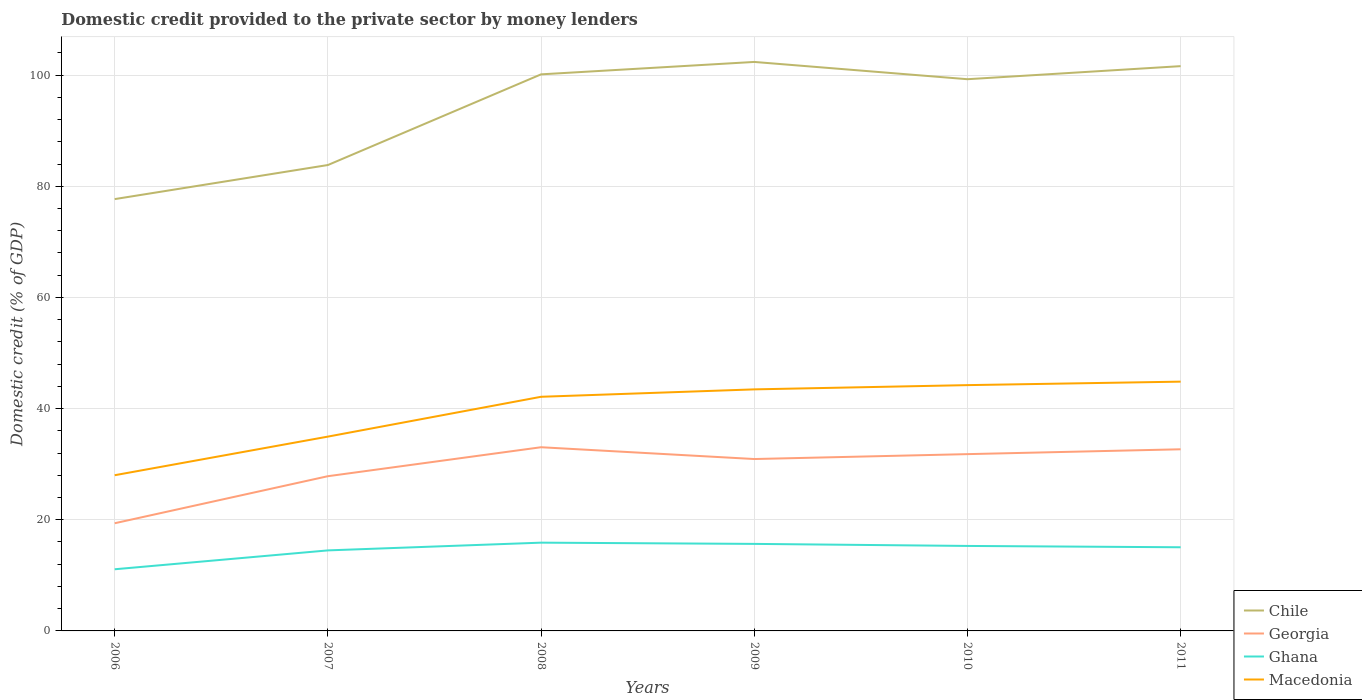How many different coloured lines are there?
Your answer should be compact. 4. Does the line corresponding to Georgia intersect with the line corresponding to Macedonia?
Keep it short and to the point. No. Across all years, what is the maximum domestic credit provided to the private sector by money lenders in Ghana?
Give a very brief answer. 11.09. What is the total domestic credit provided to the private sector by money lenders in Georgia in the graph?
Ensure brevity in your answer.  -0.87. What is the difference between the highest and the second highest domestic credit provided to the private sector by money lenders in Chile?
Your response must be concise. 24.68. What is the difference between two consecutive major ticks on the Y-axis?
Your answer should be compact. 20. Are the values on the major ticks of Y-axis written in scientific E-notation?
Make the answer very short. No. Where does the legend appear in the graph?
Your answer should be compact. Bottom right. How many legend labels are there?
Keep it short and to the point. 4. How are the legend labels stacked?
Give a very brief answer. Vertical. What is the title of the graph?
Your answer should be very brief. Domestic credit provided to the private sector by money lenders. What is the label or title of the X-axis?
Give a very brief answer. Years. What is the label or title of the Y-axis?
Your answer should be compact. Domestic credit (% of GDP). What is the Domestic credit (% of GDP) in Chile in 2006?
Provide a succinct answer. 77.69. What is the Domestic credit (% of GDP) in Georgia in 2006?
Offer a very short reply. 19.37. What is the Domestic credit (% of GDP) in Ghana in 2006?
Offer a terse response. 11.09. What is the Domestic credit (% of GDP) of Macedonia in 2006?
Keep it short and to the point. 28.01. What is the Domestic credit (% of GDP) in Chile in 2007?
Your response must be concise. 83.82. What is the Domestic credit (% of GDP) of Georgia in 2007?
Your answer should be compact. 27.84. What is the Domestic credit (% of GDP) in Ghana in 2007?
Provide a short and direct response. 14.49. What is the Domestic credit (% of GDP) in Macedonia in 2007?
Your answer should be compact. 34.96. What is the Domestic credit (% of GDP) of Chile in 2008?
Provide a short and direct response. 100.14. What is the Domestic credit (% of GDP) in Georgia in 2008?
Provide a succinct answer. 33.05. What is the Domestic credit (% of GDP) of Ghana in 2008?
Give a very brief answer. 15.88. What is the Domestic credit (% of GDP) in Macedonia in 2008?
Provide a succinct answer. 42.13. What is the Domestic credit (% of GDP) in Chile in 2009?
Offer a terse response. 102.37. What is the Domestic credit (% of GDP) in Georgia in 2009?
Offer a very short reply. 30.93. What is the Domestic credit (% of GDP) of Ghana in 2009?
Make the answer very short. 15.66. What is the Domestic credit (% of GDP) of Macedonia in 2009?
Provide a short and direct response. 43.46. What is the Domestic credit (% of GDP) in Chile in 2010?
Offer a terse response. 99.27. What is the Domestic credit (% of GDP) in Georgia in 2010?
Provide a short and direct response. 31.81. What is the Domestic credit (% of GDP) in Ghana in 2010?
Make the answer very short. 15.29. What is the Domestic credit (% of GDP) in Macedonia in 2010?
Provide a short and direct response. 44.22. What is the Domestic credit (% of GDP) of Chile in 2011?
Offer a terse response. 101.62. What is the Domestic credit (% of GDP) of Georgia in 2011?
Give a very brief answer. 32.68. What is the Domestic credit (% of GDP) of Ghana in 2011?
Keep it short and to the point. 15.05. What is the Domestic credit (% of GDP) of Macedonia in 2011?
Ensure brevity in your answer.  44.85. Across all years, what is the maximum Domestic credit (% of GDP) of Chile?
Your answer should be very brief. 102.37. Across all years, what is the maximum Domestic credit (% of GDP) in Georgia?
Offer a very short reply. 33.05. Across all years, what is the maximum Domestic credit (% of GDP) in Ghana?
Your response must be concise. 15.88. Across all years, what is the maximum Domestic credit (% of GDP) in Macedonia?
Ensure brevity in your answer.  44.85. Across all years, what is the minimum Domestic credit (% of GDP) of Chile?
Make the answer very short. 77.69. Across all years, what is the minimum Domestic credit (% of GDP) of Georgia?
Provide a succinct answer. 19.37. Across all years, what is the minimum Domestic credit (% of GDP) of Ghana?
Keep it short and to the point. 11.09. Across all years, what is the minimum Domestic credit (% of GDP) of Macedonia?
Ensure brevity in your answer.  28.01. What is the total Domestic credit (% of GDP) of Chile in the graph?
Keep it short and to the point. 564.91. What is the total Domestic credit (% of GDP) of Georgia in the graph?
Offer a very short reply. 175.68. What is the total Domestic credit (% of GDP) of Ghana in the graph?
Your response must be concise. 87.46. What is the total Domestic credit (% of GDP) in Macedonia in the graph?
Give a very brief answer. 237.64. What is the difference between the Domestic credit (% of GDP) of Chile in 2006 and that in 2007?
Ensure brevity in your answer.  -6.13. What is the difference between the Domestic credit (% of GDP) of Georgia in 2006 and that in 2007?
Offer a terse response. -8.46. What is the difference between the Domestic credit (% of GDP) in Ghana in 2006 and that in 2007?
Offer a terse response. -3.39. What is the difference between the Domestic credit (% of GDP) of Macedonia in 2006 and that in 2007?
Your response must be concise. -6.95. What is the difference between the Domestic credit (% of GDP) in Chile in 2006 and that in 2008?
Provide a succinct answer. -22.45. What is the difference between the Domestic credit (% of GDP) of Georgia in 2006 and that in 2008?
Ensure brevity in your answer.  -13.68. What is the difference between the Domestic credit (% of GDP) in Ghana in 2006 and that in 2008?
Your answer should be compact. -4.79. What is the difference between the Domestic credit (% of GDP) of Macedonia in 2006 and that in 2008?
Give a very brief answer. -14.11. What is the difference between the Domestic credit (% of GDP) of Chile in 2006 and that in 2009?
Ensure brevity in your answer.  -24.68. What is the difference between the Domestic credit (% of GDP) in Georgia in 2006 and that in 2009?
Offer a very short reply. -11.55. What is the difference between the Domestic credit (% of GDP) of Ghana in 2006 and that in 2009?
Provide a short and direct response. -4.56. What is the difference between the Domestic credit (% of GDP) in Macedonia in 2006 and that in 2009?
Make the answer very short. -15.45. What is the difference between the Domestic credit (% of GDP) of Chile in 2006 and that in 2010?
Keep it short and to the point. -21.57. What is the difference between the Domestic credit (% of GDP) in Georgia in 2006 and that in 2010?
Give a very brief answer. -12.43. What is the difference between the Domestic credit (% of GDP) in Ghana in 2006 and that in 2010?
Provide a succinct answer. -4.2. What is the difference between the Domestic credit (% of GDP) of Macedonia in 2006 and that in 2010?
Provide a succinct answer. -16.21. What is the difference between the Domestic credit (% of GDP) of Chile in 2006 and that in 2011?
Give a very brief answer. -23.92. What is the difference between the Domestic credit (% of GDP) in Georgia in 2006 and that in 2011?
Provide a succinct answer. -13.31. What is the difference between the Domestic credit (% of GDP) in Ghana in 2006 and that in 2011?
Make the answer very short. -3.96. What is the difference between the Domestic credit (% of GDP) in Macedonia in 2006 and that in 2011?
Offer a terse response. -16.84. What is the difference between the Domestic credit (% of GDP) of Chile in 2007 and that in 2008?
Your response must be concise. -16.32. What is the difference between the Domestic credit (% of GDP) of Georgia in 2007 and that in 2008?
Ensure brevity in your answer.  -5.21. What is the difference between the Domestic credit (% of GDP) in Ghana in 2007 and that in 2008?
Offer a terse response. -1.39. What is the difference between the Domestic credit (% of GDP) in Macedonia in 2007 and that in 2008?
Your answer should be very brief. -7.17. What is the difference between the Domestic credit (% of GDP) of Chile in 2007 and that in 2009?
Give a very brief answer. -18.55. What is the difference between the Domestic credit (% of GDP) of Georgia in 2007 and that in 2009?
Provide a short and direct response. -3.09. What is the difference between the Domestic credit (% of GDP) in Ghana in 2007 and that in 2009?
Your answer should be very brief. -1.17. What is the difference between the Domestic credit (% of GDP) in Macedonia in 2007 and that in 2009?
Give a very brief answer. -8.5. What is the difference between the Domestic credit (% of GDP) in Chile in 2007 and that in 2010?
Offer a terse response. -15.44. What is the difference between the Domestic credit (% of GDP) in Georgia in 2007 and that in 2010?
Make the answer very short. -3.97. What is the difference between the Domestic credit (% of GDP) in Ghana in 2007 and that in 2010?
Your answer should be very brief. -0.8. What is the difference between the Domestic credit (% of GDP) of Macedonia in 2007 and that in 2010?
Your answer should be very brief. -9.26. What is the difference between the Domestic credit (% of GDP) of Chile in 2007 and that in 2011?
Provide a short and direct response. -17.79. What is the difference between the Domestic credit (% of GDP) in Georgia in 2007 and that in 2011?
Your response must be concise. -4.84. What is the difference between the Domestic credit (% of GDP) of Ghana in 2007 and that in 2011?
Offer a terse response. -0.56. What is the difference between the Domestic credit (% of GDP) of Macedonia in 2007 and that in 2011?
Your response must be concise. -9.89. What is the difference between the Domestic credit (% of GDP) of Chile in 2008 and that in 2009?
Make the answer very short. -2.23. What is the difference between the Domestic credit (% of GDP) in Georgia in 2008 and that in 2009?
Provide a succinct answer. 2.12. What is the difference between the Domestic credit (% of GDP) in Ghana in 2008 and that in 2009?
Your answer should be compact. 0.22. What is the difference between the Domestic credit (% of GDP) in Macedonia in 2008 and that in 2009?
Your response must be concise. -1.33. What is the difference between the Domestic credit (% of GDP) in Chile in 2008 and that in 2010?
Offer a very short reply. 0.87. What is the difference between the Domestic credit (% of GDP) of Georgia in 2008 and that in 2010?
Keep it short and to the point. 1.24. What is the difference between the Domestic credit (% of GDP) in Ghana in 2008 and that in 2010?
Give a very brief answer. 0.59. What is the difference between the Domestic credit (% of GDP) of Macedonia in 2008 and that in 2010?
Offer a terse response. -2.1. What is the difference between the Domestic credit (% of GDP) of Chile in 2008 and that in 2011?
Your answer should be very brief. -1.48. What is the difference between the Domestic credit (% of GDP) in Georgia in 2008 and that in 2011?
Your response must be concise. 0.37. What is the difference between the Domestic credit (% of GDP) of Ghana in 2008 and that in 2011?
Offer a terse response. 0.83. What is the difference between the Domestic credit (% of GDP) of Macedonia in 2008 and that in 2011?
Give a very brief answer. -2.73. What is the difference between the Domestic credit (% of GDP) in Chile in 2009 and that in 2010?
Your answer should be compact. 3.11. What is the difference between the Domestic credit (% of GDP) of Georgia in 2009 and that in 2010?
Give a very brief answer. -0.88. What is the difference between the Domestic credit (% of GDP) in Ghana in 2009 and that in 2010?
Your answer should be compact. 0.37. What is the difference between the Domestic credit (% of GDP) of Macedonia in 2009 and that in 2010?
Offer a terse response. -0.76. What is the difference between the Domestic credit (% of GDP) in Chile in 2009 and that in 2011?
Offer a very short reply. 0.76. What is the difference between the Domestic credit (% of GDP) in Georgia in 2009 and that in 2011?
Ensure brevity in your answer.  -1.75. What is the difference between the Domestic credit (% of GDP) in Ghana in 2009 and that in 2011?
Keep it short and to the point. 0.61. What is the difference between the Domestic credit (% of GDP) of Macedonia in 2009 and that in 2011?
Keep it short and to the point. -1.39. What is the difference between the Domestic credit (% of GDP) in Chile in 2010 and that in 2011?
Make the answer very short. -2.35. What is the difference between the Domestic credit (% of GDP) of Georgia in 2010 and that in 2011?
Ensure brevity in your answer.  -0.87. What is the difference between the Domestic credit (% of GDP) of Ghana in 2010 and that in 2011?
Ensure brevity in your answer.  0.24. What is the difference between the Domestic credit (% of GDP) of Macedonia in 2010 and that in 2011?
Give a very brief answer. -0.63. What is the difference between the Domestic credit (% of GDP) in Chile in 2006 and the Domestic credit (% of GDP) in Georgia in 2007?
Make the answer very short. 49.86. What is the difference between the Domestic credit (% of GDP) in Chile in 2006 and the Domestic credit (% of GDP) in Ghana in 2007?
Make the answer very short. 63.21. What is the difference between the Domestic credit (% of GDP) of Chile in 2006 and the Domestic credit (% of GDP) of Macedonia in 2007?
Your response must be concise. 42.73. What is the difference between the Domestic credit (% of GDP) in Georgia in 2006 and the Domestic credit (% of GDP) in Ghana in 2007?
Make the answer very short. 4.89. What is the difference between the Domestic credit (% of GDP) in Georgia in 2006 and the Domestic credit (% of GDP) in Macedonia in 2007?
Make the answer very short. -15.59. What is the difference between the Domestic credit (% of GDP) in Ghana in 2006 and the Domestic credit (% of GDP) in Macedonia in 2007?
Provide a succinct answer. -23.87. What is the difference between the Domestic credit (% of GDP) of Chile in 2006 and the Domestic credit (% of GDP) of Georgia in 2008?
Your answer should be compact. 44.64. What is the difference between the Domestic credit (% of GDP) of Chile in 2006 and the Domestic credit (% of GDP) of Ghana in 2008?
Keep it short and to the point. 61.81. What is the difference between the Domestic credit (% of GDP) of Chile in 2006 and the Domestic credit (% of GDP) of Macedonia in 2008?
Your response must be concise. 35.57. What is the difference between the Domestic credit (% of GDP) of Georgia in 2006 and the Domestic credit (% of GDP) of Ghana in 2008?
Offer a terse response. 3.49. What is the difference between the Domestic credit (% of GDP) of Georgia in 2006 and the Domestic credit (% of GDP) of Macedonia in 2008?
Give a very brief answer. -22.75. What is the difference between the Domestic credit (% of GDP) of Ghana in 2006 and the Domestic credit (% of GDP) of Macedonia in 2008?
Your answer should be compact. -31.03. What is the difference between the Domestic credit (% of GDP) of Chile in 2006 and the Domestic credit (% of GDP) of Georgia in 2009?
Offer a terse response. 46.77. What is the difference between the Domestic credit (% of GDP) of Chile in 2006 and the Domestic credit (% of GDP) of Ghana in 2009?
Your answer should be compact. 62.04. What is the difference between the Domestic credit (% of GDP) of Chile in 2006 and the Domestic credit (% of GDP) of Macedonia in 2009?
Your response must be concise. 34.23. What is the difference between the Domestic credit (% of GDP) of Georgia in 2006 and the Domestic credit (% of GDP) of Ghana in 2009?
Ensure brevity in your answer.  3.72. What is the difference between the Domestic credit (% of GDP) in Georgia in 2006 and the Domestic credit (% of GDP) in Macedonia in 2009?
Offer a very short reply. -24.09. What is the difference between the Domestic credit (% of GDP) in Ghana in 2006 and the Domestic credit (% of GDP) in Macedonia in 2009?
Ensure brevity in your answer.  -32.37. What is the difference between the Domestic credit (% of GDP) of Chile in 2006 and the Domestic credit (% of GDP) of Georgia in 2010?
Your answer should be very brief. 45.89. What is the difference between the Domestic credit (% of GDP) in Chile in 2006 and the Domestic credit (% of GDP) in Ghana in 2010?
Your answer should be compact. 62.4. What is the difference between the Domestic credit (% of GDP) in Chile in 2006 and the Domestic credit (% of GDP) in Macedonia in 2010?
Your answer should be compact. 33.47. What is the difference between the Domestic credit (% of GDP) in Georgia in 2006 and the Domestic credit (% of GDP) in Ghana in 2010?
Your answer should be compact. 4.08. What is the difference between the Domestic credit (% of GDP) in Georgia in 2006 and the Domestic credit (% of GDP) in Macedonia in 2010?
Offer a very short reply. -24.85. What is the difference between the Domestic credit (% of GDP) of Ghana in 2006 and the Domestic credit (% of GDP) of Macedonia in 2010?
Your answer should be very brief. -33.13. What is the difference between the Domestic credit (% of GDP) in Chile in 2006 and the Domestic credit (% of GDP) in Georgia in 2011?
Offer a terse response. 45.01. What is the difference between the Domestic credit (% of GDP) in Chile in 2006 and the Domestic credit (% of GDP) in Ghana in 2011?
Give a very brief answer. 62.64. What is the difference between the Domestic credit (% of GDP) in Chile in 2006 and the Domestic credit (% of GDP) in Macedonia in 2011?
Provide a short and direct response. 32.84. What is the difference between the Domestic credit (% of GDP) of Georgia in 2006 and the Domestic credit (% of GDP) of Ghana in 2011?
Make the answer very short. 4.32. What is the difference between the Domestic credit (% of GDP) in Georgia in 2006 and the Domestic credit (% of GDP) in Macedonia in 2011?
Your answer should be compact. -25.48. What is the difference between the Domestic credit (% of GDP) in Ghana in 2006 and the Domestic credit (% of GDP) in Macedonia in 2011?
Your response must be concise. -33.76. What is the difference between the Domestic credit (% of GDP) in Chile in 2007 and the Domestic credit (% of GDP) in Georgia in 2008?
Your response must be concise. 50.77. What is the difference between the Domestic credit (% of GDP) in Chile in 2007 and the Domestic credit (% of GDP) in Ghana in 2008?
Make the answer very short. 67.94. What is the difference between the Domestic credit (% of GDP) of Chile in 2007 and the Domestic credit (% of GDP) of Macedonia in 2008?
Your response must be concise. 41.7. What is the difference between the Domestic credit (% of GDP) of Georgia in 2007 and the Domestic credit (% of GDP) of Ghana in 2008?
Ensure brevity in your answer.  11.96. What is the difference between the Domestic credit (% of GDP) in Georgia in 2007 and the Domestic credit (% of GDP) in Macedonia in 2008?
Your answer should be compact. -14.29. What is the difference between the Domestic credit (% of GDP) in Ghana in 2007 and the Domestic credit (% of GDP) in Macedonia in 2008?
Your response must be concise. -27.64. What is the difference between the Domestic credit (% of GDP) in Chile in 2007 and the Domestic credit (% of GDP) in Georgia in 2009?
Your response must be concise. 52.9. What is the difference between the Domestic credit (% of GDP) in Chile in 2007 and the Domestic credit (% of GDP) in Ghana in 2009?
Make the answer very short. 68.17. What is the difference between the Domestic credit (% of GDP) in Chile in 2007 and the Domestic credit (% of GDP) in Macedonia in 2009?
Provide a succinct answer. 40.36. What is the difference between the Domestic credit (% of GDP) of Georgia in 2007 and the Domestic credit (% of GDP) of Ghana in 2009?
Your response must be concise. 12.18. What is the difference between the Domestic credit (% of GDP) in Georgia in 2007 and the Domestic credit (% of GDP) in Macedonia in 2009?
Offer a terse response. -15.62. What is the difference between the Domestic credit (% of GDP) in Ghana in 2007 and the Domestic credit (% of GDP) in Macedonia in 2009?
Make the answer very short. -28.97. What is the difference between the Domestic credit (% of GDP) of Chile in 2007 and the Domestic credit (% of GDP) of Georgia in 2010?
Make the answer very short. 52.02. What is the difference between the Domestic credit (% of GDP) in Chile in 2007 and the Domestic credit (% of GDP) in Ghana in 2010?
Your answer should be very brief. 68.54. What is the difference between the Domestic credit (% of GDP) in Chile in 2007 and the Domestic credit (% of GDP) in Macedonia in 2010?
Give a very brief answer. 39.6. What is the difference between the Domestic credit (% of GDP) in Georgia in 2007 and the Domestic credit (% of GDP) in Ghana in 2010?
Ensure brevity in your answer.  12.55. What is the difference between the Domestic credit (% of GDP) of Georgia in 2007 and the Domestic credit (% of GDP) of Macedonia in 2010?
Keep it short and to the point. -16.39. What is the difference between the Domestic credit (% of GDP) in Ghana in 2007 and the Domestic credit (% of GDP) in Macedonia in 2010?
Provide a short and direct response. -29.74. What is the difference between the Domestic credit (% of GDP) of Chile in 2007 and the Domestic credit (% of GDP) of Georgia in 2011?
Offer a very short reply. 51.14. What is the difference between the Domestic credit (% of GDP) of Chile in 2007 and the Domestic credit (% of GDP) of Ghana in 2011?
Ensure brevity in your answer.  68.77. What is the difference between the Domestic credit (% of GDP) of Chile in 2007 and the Domestic credit (% of GDP) of Macedonia in 2011?
Provide a short and direct response. 38.97. What is the difference between the Domestic credit (% of GDP) of Georgia in 2007 and the Domestic credit (% of GDP) of Ghana in 2011?
Make the answer very short. 12.79. What is the difference between the Domestic credit (% of GDP) of Georgia in 2007 and the Domestic credit (% of GDP) of Macedonia in 2011?
Your answer should be compact. -17.01. What is the difference between the Domestic credit (% of GDP) of Ghana in 2007 and the Domestic credit (% of GDP) of Macedonia in 2011?
Give a very brief answer. -30.36. What is the difference between the Domestic credit (% of GDP) in Chile in 2008 and the Domestic credit (% of GDP) in Georgia in 2009?
Offer a terse response. 69.21. What is the difference between the Domestic credit (% of GDP) in Chile in 2008 and the Domestic credit (% of GDP) in Ghana in 2009?
Make the answer very short. 84.48. What is the difference between the Domestic credit (% of GDP) in Chile in 2008 and the Domestic credit (% of GDP) in Macedonia in 2009?
Your response must be concise. 56.68. What is the difference between the Domestic credit (% of GDP) in Georgia in 2008 and the Domestic credit (% of GDP) in Ghana in 2009?
Provide a succinct answer. 17.39. What is the difference between the Domestic credit (% of GDP) in Georgia in 2008 and the Domestic credit (% of GDP) in Macedonia in 2009?
Your answer should be compact. -10.41. What is the difference between the Domestic credit (% of GDP) in Ghana in 2008 and the Domestic credit (% of GDP) in Macedonia in 2009?
Provide a succinct answer. -27.58. What is the difference between the Domestic credit (% of GDP) in Chile in 2008 and the Domestic credit (% of GDP) in Georgia in 2010?
Your response must be concise. 68.33. What is the difference between the Domestic credit (% of GDP) of Chile in 2008 and the Domestic credit (% of GDP) of Ghana in 2010?
Provide a short and direct response. 84.85. What is the difference between the Domestic credit (% of GDP) of Chile in 2008 and the Domestic credit (% of GDP) of Macedonia in 2010?
Your answer should be compact. 55.92. What is the difference between the Domestic credit (% of GDP) in Georgia in 2008 and the Domestic credit (% of GDP) in Ghana in 2010?
Your response must be concise. 17.76. What is the difference between the Domestic credit (% of GDP) of Georgia in 2008 and the Domestic credit (% of GDP) of Macedonia in 2010?
Offer a terse response. -11.17. What is the difference between the Domestic credit (% of GDP) of Ghana in 2008 and the Domestic credit (% of GDP) of Macedonia in 2010?
Keep it short and to the point. -28.34. What is the difference between the Domestic credit (% of GDP) in Chile in 2008 and the Domestic credit (% of GDP) in Georgia in 2011?
Offer a very short reply. 67.46. What is the difference between the Domestic credit (% of GDP) in Chile in 2008 and the Domestic credit (% of GDP) in Ghana in 2011?
Your response must be concise. 85.09. What is the difference between the Domestic credit (% of GDP) of Chile in 2008 and the Domestic credit (% of GDP) of Macedonia in 2011?
Your response must be concise. 55.29. What is the difference between the Domestic credit (% of GDP) of Georgia in 2008 and the Domestic credit (% of GDP) of Ghana in 2011?
Your answer should be very brief. 18. What is the difference between the Domestic credit (% of GDP) in Georgia in 2008 and the Domestic credit (% of GDP) in Macedonia in 2011?
Ensure brevity in your answer.  -11.8. What is the difference between the Domestic credit (% of GDP) in Ghana in 2008 and the Domestic credit (% of GDP) in Macedonia in 2011?
Keep it short and to the point. -28.97. What is the difference between the Domestic credit (% of GDP) in Chile in 2009 and the Domestic credit (% of GDP) in Georgia in 2010?
Ensure brevity in your answer.  70.56. What is the difference between the Domestic credit (% of GDP) in Chile in 2009 and the Domestic credit (% of GDP) in Ghana in 2010?
Keep it short and to the point. 87.08. What is the difference between the Domestic credit (% of GDP) in Chile in 2009 and the Domestic credit (% of GDP) in Macedonia in 2010?
Make the answer very short. 58.15. What is the difference between the Domestic credit (% of GDP) of Georgia in 2009 and the Domestic credit (% of GDP) of Ghana in 2010?
Your answer should be compact. 15.64. What is the difference between the Domestic credit (% of GDP) of Georgia in 2009 and the Domestic credit (% of GDP) of Macedonia in 2010?
Your answer should be very brief. -13.3. What is the difference between the Domestic credit (% of GDP) of Ghana in 2009 and the Domestic credit (% of GDP) of Macedonia in 2010?
Offer a terse response. -28.57. What is the difference between the Domestic credit (% of GDP) of Chile in 2009 and the Domestic credit (% of GDP) of Georgia in 2011?
Provide a succinct answer. 69.69. What is the difference between the Domestic credit (% of GDP) of Chile in 2009 and the Domestic credit (% of GDP) of Ghana in 2011?
Ensure brevity in your answer.  87.32. What is the difference between the Domestic credit (% of GDP) of Chile in 2009 and the Domestic credit (% of GDP) of Macedonia in 2011?
Offer a terse response. 57.52. What is the difference between the Domestic credit (% of GDP) in Georgia in 2009 and the Domestic credit (% of GDP) in Ghana in 2011?
Offer a very short reply. 15.88. What is the difference between the Domestic credit (% of GDP) in Georgia in 2009 and the Domestic credit (% of GDP) in Macedonia in 2011?
Offer a terse response. -13.93. What is the difference between the Domestic credit (% of GDP) of Ghana in 2009 and the Domestic credit (% of GDP) of Macedonia in 2011?
Make the answer very short. -29.19. What is the difference between the Domestic credit (% of GDP) in Chile in 2010 and the Domestic credit (% of GDP) in Georgia in 2011?
Your answer should be compact. 66.58. What is the difference between the Domestic credit (% of GDP) in Chile in 2010 and the Domestic credit (% of GDP) in Ghana in 2011?
Provide a short and direct response. 84.22. What is the difference between the Domestic credit (% of GDP) in Chile in 2010 and the Domestic credit (% of GDP) in Macedonia in 2011?
Ensure brevity in your answer.  54.41. What is the difference between the Domestic credit (% of GDP) of Georgia in 2010 and the Domestic credit (% of GDP) of Ghana in 2011?
Offer a terse response. 16.76. What is the difference between the Domestic credit (% of GDP) of Georgia in 2010 and the Domestic credit (% of GDP) of Macedonia in 2011?
Your answer should be compact. -13.04. What is the difference between the Domestic credit (% of GDP) in Ghana in 2010 and the Domestic credit (% of GDP) in Macedonia in 2011?
Provide a succinct answer. -29.56. What is the average Domestic credit (% of GDP) in Chile per year?
Offer a terse response. 94.15. What is the average Domestic credit (% of GDP) of Georgia per year?
Keep it short and to the point. 29.28. What is the average Domestic credit (% of GDP) of Ghana per year?
Make the answer very short. 14.58. What is the average Domestic credit (% of GDP) in Macedonia per year?
Your answer should be compact. 39.61. In the year 2006, what is the difference between the Domestic credit (% of GDP) in Chile and Domestic credit (% of GDP) in Georgia?
Your answer should be compact. 58.32. In the year 2006, what is the difference between the Domestic credit (% of GDP) of Chile and Domestic credit (% of GDP) of Ghana?
Give a very brief answer. 66.6. In the year 2006, what is the difference between the Domestic credit (% of GDP) in Chile and Domestic credit (% of GDP) in Macedonia?
Provide a short and direct response. 49.68. In the year 2006, what is the difference between the Domestic credit (% of GDP) of Georgia and Domestic credit (% of GDP) of Ghana?
Provide a short and direct response. 8.28. In the year 2006, what is the difference between the Domestic credit (% of GDP) of Georgia and Domestic credit (% of GDP) of Macedonia?
Provide a succinct answer. -8.64. In the year 2006, what is the difference between the Domestic credit (% of GDP) in Ghana and Domestic credit (% of GDP) in Macedonia?
Provide a succinct answer. -16.92. In the year 2007, what is the difference between the Domestic credit (% of GDP) of Chile and Domestic credit (% of GDP) of Georgia?
Your answer should be compact. 55.99. In the year 2007, what is the difference between the Domestic credit (% of GDP) of Chile and Domestic credit (% of GDP) of Ghana?
Provide a succinct answer. 69.34. In the year 2007, what is the difference between the Domestic credit (% of GDP) in Chile and Domestic credit (% of GDP) in Macedonia?
Make the answer very short. 48.86. In the year 2007, what is the difference between the Domestic credit (% of GDP) of Georgia and Domestic credit (% of GDP) of Ghana?
Your answer should be compact. 13.35. In the year 2007, what is the difference between the Domestic credit (% of GDP) of Georgia and Domestic credit (% of GDP) of Macedonia?
Your answer should be compact. -7.12. In the year 2007, what is the difference between the Domestic credit (% of GDP) of Ghana and Domestic credit (% of GDP) of Macedonia?
Your answer should be compact. -20.47. In the year 2008, what is the difference between the Domestic credit (% of GDP) in Chile and Domestic credit (% of GDP) in Georgia?
Offer a very short reply. 67.09. In the year 2008, what is the difference between the Domestic credit (% of GDP) in Chile and Domestic credit (% of GDP) in Ghana?
Give a very brief answer. 84.26. In the year 2008, what is the difference between the Domestic credit (% of GDP) in Chile and Domestic credit (% of GDP) in Macedonia?
Keep it short and to the point. 58.01. In the year 2008, what is the difference between the Domestic credit (% of GDP) of Georgia and Domestic credit (% of GDP) of Ghana?
Provide a succinct answer. 17.17. In the year 2008, what is the difference between the Domestic credit (% of GDP) in Georgia and Domestic credit (% of GDP) in Macedonia?
Provide a succinct answer. -9.08. In the year 2008, what is the difference between the Domestic credit (% of GDP) of Ghana and Domestic credit (% of GDP) of Macedonia?
Your response must be concise. -26.25. In the year 2009, what is the difference between the Domestic credit (% of GDP) in Chile and Domestic credit (% of GDP) in Georgia?
Keep it short and to the point. 71.44. In the year 2009, what is the difference between the Domestic credit (% of GDP) of Chile and Domestic credit (% of GDP) of Ghana?
Make the answer very short. 86.71. In the year 2009, what is the difference between the Domestic credit (% of GDP) of Chile and Domestic credit (% of GDP) of Macedonia?
Your answer should be very brief. 58.91. In the year 2009, what is the difference between the Domestic credit (% of GDP) of Georgia and Domestic credit (% of GDP) of Ghana?
Provide a short and direct response. 15.27. In the year 2009, what is the difference between the Domestic credit (% of GDP) of Georgia and Domestic credit (% of GDP) of Macedonia?
Provide a short and direct response. -12.53. In the year 2009, what is the difference between the Domestic credit (% of GDP) in Ghana and Domestic credit (% of GDP) in Macedonia?
Offer a terse response. -27.8. In the year 2010, what is the difference between the Domestic credit (% of GDP) of Chile and Domestic credit (% of GDP) of Georgia?
Make the answer very short. 67.46. In the year 2010, what is the difference between the Domestic credit (% of GDP) of Chile and Domestic credit (% of GDP) of Ghana?
Provide a succinct answer. 83.98. In the year 2010, what is the difference between the Domestic credit (% of GDP) in Chile and Domestic credit (% of GDP) in Macedonia?
Provide a succinct answer. 55.04. In the year 2010, what is the difference between the Domestic credit (% of GDP) in Georgia and Domestic credit (% of GDP) in Ghana?
Ensure brevity in your answer.  16.52. In the year 2010, what is the difference between the Domestic credit (% of GDP) in Georgia and Domestic credit (% of GDP) in Macedonia?
Provide a short and direct response. -12.42. In the year 2010, what is the difference between the Domestic credit (% of GDP) of Ghana and Domestic credit (% of GDP) of Macedonia?
Your response must be concise. -28.94. In the year 2011, what is the difference between the Domestic credit (% of GDP) of Chile and Domestic credit (% of GDP) of Georgia?
Offer a very short reply. 68.94. In the year 2011, what is the difference between the Domestic credit (% of GDP) of Chile and Domestic credit (% of GDP) of Ghana?
Provide a short and direct response. 86.57. In the year 2011, what is the difference between the Domestic credit (% of GDP) in Chile and Domestic credit (% of GDP) in Macedonia?
Offer a terse response. 56.76. In the year 2011, what is the difference between the Domestic credit (% of GDP) of Georgia and Domestic credit (% of GDP) of Ghana?
Offer a terse response. 17.63. In the year 2011, what is the difference between the Domestic credit (% of GDP) in Georgia and Domestic credit (% of GDP) in Macedonia?
Your response must be concise. -12.17. In the year 2011, what is the difference between the Domestic credit (% of GDP) in Ghana and Domestic credit (% of GDP) in Macedonia?
Offer a terse response. -29.8. What is the ratio of the Domestic credit (% of GDP) in Chile in 2006 to that in 2007?
Provide a succinct answer. 0.93. What is the ratio of the Domestic credit (% of GDP) of Georgia in 2006 to that in 2007?
Give a very brief answer. 0.7. What is the ratio of the Domestic credit (% of GDP) in Ghana in 2006 to that in 2007?
Keep it short and to the point. 0.77. What is the ratio of the Domestic credit (% of GDP) of Macedonia in 2006 to that in 2007?
Give a very brief answer. 0.8. What is the ratio of the Domestic credit (% of GDP) of Chile in 2006 to that in 2008?
Provide a short and direct response. 0.78. What is the ratio of the Domestic credit (% of GDP) of Georgia in 2006 to that in 2008?
Keep it short and to the point. 0.59. What is the ratio of the Domestic credit (% of GDP) in Ghana in 2006 to that in 2008?
Offer a very short reply. 0.7. What is the ratio of the Domestic credit (% of GDP) in Macedonia in 2006 to that in 2008?
Make the answer very short. 0.67. What is the ratio of the Domestic credit (% of GDP) of Chile in 2006 to that in 2009?
Provide a succinct answer. 0.76. What is the ratio of the Domestic credit (% of GDP) in Georgia in 2006 to that in 2009?
Provide a short and direct response. 0.63. What is the ratio of the Domestic credit (% of GDP) in Ghana in 2006 to that in 2009?
Give a very brief answer. 0.71. What is the ratio of the Domestic credit (% of GDP) in Macedonia in 2006 to that in 2009?
Offer a terse response. 0.64. What is the ratio of the Domestic credit (% of GDP) of Chile in 2006 to that in 2010?
Your response must be concise. 0.78. What is the ratio of the Domestic credit (% of GDP) in Georgia in 2006 to that in 2010?
Provide a short and direct response. 0.61. What is the ratio of the Domestic credit (% of GDP) of Ghana in 2006 to that in 2010?
Make the answer very short. 0.73. What is the ratio of the Domestic credit (% of GDP) of Macedonia in 2006 to that in 2010?
Provide a succinct answer. 0.63. What is the ratio of the Domestic credit (% of GDP) of Chile in 2006 to that in 2011?
Provide a short and direct response. 0.76. What is the ratio of the Domestic credit (% of GDP) of Georgia in 2006 to that in 2011?
Provide a short and direct response. 0.59. What is the ratio of the Domestic credit (% of GDP) in Ghana in 2006 to that in 2011?
Your response must be concise. 0.74. What is the ratio of the Domestic credit (% of GDP) in Macedonia in 2006 to that in 2011?
Provide a short and direct response. 0.62. What is the ratio of the Domestic credit (% of GDP) in Chile in 2007 to that in 2008?
Give a very brief answer. 0.84. What is the ratio of the Domestic credit (% of GDP) of Georgia in 2007 to that in 2008?
Your response must be concise. 0.84. What is the ratio of the Domestic credit (% of GDP) in Ghana in 2007 to that in 2008?
Offer a very short reply. 0.91. What is the ratio of the Domestic credit (% of GDP) in Macedonia in 2007 to that in 2008?
Give a very brief answer. 0.83. What is the ratio of the Domestic credit (% of GDP) of Chile in 2007 to that in 2009?
Offer a very short reply. 0.82. What is the ratio of the Domestic credit (% of GDP) in Georgia in 2007 to that in 2009?
Provide a short and direct response. 0.9. What is the ratio of the Domestic credit (% of GDP) of Ghana in 2007 to that in 2009?
Your answer should be very brief. 0.93. What is the ratio of the Domestic credit (% of GDP) in Macedonia in 2007 to that in 2009?
Offer a terse response. 0.8. What is the ratio of the Domestic credit (% of GDP) of Chile in 2007 to that in 2010?
Offer a terse response. 0.84. What is the ratio of the Domestic credit (% of GDP) in Georgia in 2007 to that in 2010?
Ensure brevity in your answer.  0.88. What is the ratio of the Domestic credit (% of GDP) in Ghana in 2007 to that in 2010?
Provide a succinct answer. 0.95. What is the ratio of the Domestic credit (% of GDP) of Macedonia in 2007 to that in 2010?
Keep it short and to the point. 0.79. What is the ratio of the Domestic credit (% of GDP) in Chile in 2007 to that in 2011?
Give a very brief answer. 0.82. What is the ratio of the Domestic credit (% of GDP) in Georgia in 2007 to that in 2011?
Ensure brevity in your answer.  0.85. What is the ratio of the Domestic credit (% of GDP) of Ghana in 2007 to that in 2011?
Your answer should be compact. 0.96. What is the ratio of the Domestic credit (% of GDP) in Macedonia in 2007 to that in 2011?
Keep it short and to the point. 0.78. What is the ratio of the Domestic credit (% of GDP) of Chile in 2008 to that in 2009?
Your answer should be very brief. 0.98. What is the ratio of the Domestic credit (% of GDP) in Georgia in 2008 to that in 2009?
Offer a terse response. 1.07. What is the ratio of the Domestic credit (% of GDP) of Ghana in 2008 to that in 2009?
Your answer should be very brief. 1.01. What is the ratio of the Domestic credit (% of GDP) in Macedonia in 2008 to that in 2009?
Make the answer very short. 0.97. What is the ratio of the Domestic credit (% of GDP) in Chile in 2008 to that in 2010?
Make the answer very short. 1.01. What is the ratio of the Domestic credit (% of GDP) in Georgia in 2008 to that in 2010?
Your response must be concise. 1.04. What is the ratio of the Domestic credit (% of GDP) in Ghana in 2008 to that in 2010?
Make the answer very short. 1.04. What is the ratio of the Domestic credit (% of GDP) of Macedonia in 2008 to that in 2010?
Provide a short and direct response. 0.95. What is the ratio of the Domestic credit (% of GDP) of Chile in 2008 to that in 2011?
Give a very brief answer. 0.99. What is the ratio of the Domestic credit (% of GDP) in Georgia in 2008 to that in 2011?
Your answer should be very brief. 1.01. What is the ratio of the Domestic credit (% of GDP) in Ghana in 2008 to that in 2011?
Ensure brevity in your answer.  1.06. What is the ratio of the Domestic credit (% of GDP) of Macedonia in 2008 to that in 2011?
Your response must be concise. 0.94. What is the ratio of the Domestic credit (% of GDP) in Chile in 2009 to that in 2010?
Make the answer very short. 1.03. What is the ratio of the Domestic credit (% of GDP) of Georgia in 2009 to that in 2010?
Make the answer very short. 0.97. What is the ratio of the Domestic credit (% of GDP) in Ghana in 2009 to that in 2010?
Offer a terse response. 1.02. What is the ratio of the Domestic credit (% of GDP) of Macedonia in 2009 to that in 2010?
Provide a succinct answer. 0.98. What is the ratio of the Domestic credit (% of GDP) in Chile in 2009 to that in 2011?
Provide a succinct answer. 1.01. What is the ratio of the Domestic credit (% of GDP) of Georgia in 2009 to that in 2011?
Offer a very short reply. 0.95. What is the ratio of the Domestic credit (% of GDP) in Ghana in 2009 to that in 2011?
Keep it short and to the point. 1.04. What is the ratio of the Domestic credit (% of GDP) in Macedonia in 2009 to that in 2011?
Keep it short and to the point. 0.97. What is the ratio of the Domestic credit (% of GDP) in Chile in 2010 to that in 2011?
Give a very brief answer. 0.98. What is the ratio of the Domestic credit (% of GDP) of Georgia in 2010 to that in 2011?
Your answer should be very brief. 0.97. What is the ratio of the Domestic credit (% of GDP) in Ghana in 2010 to that in 2011?
Offer a very short reply. 1.02. What is the difference between the highest and the second highest Domestic credit (% of GDP) in Chile?
Provide a succinct answer. 0.76. What is the difference between the highest and the second highest Domestic credit (% of GDP) of Georgia?
Your answer should be very brief. 0.37. What is the difference between the highest and the second highest Domestic credit (% of GDP) of Ghana?
Give a very brief answer. 0.22. What is the difference between the highest and the second highest Domestic credit (% of GDP) of Macedonia?
Your answer should be compact. 0.63. What is the difference between the highest and the lowest Domestic credit (% of GDP) of Chile?
Offer a terse response. 24.68. What is the difference between the highest and the lowest Domestic credit (% of GDP) of Georgia?
Offer a terse response. 13.68. What is the difference between the highest and the lowest Domestic credit (% of GDP) of Ghana?
Ensure brevity in your answer.  4.79. What is the difference between the highest and the lowest Domestic credit (% of GDP) of Macedonia?
Ensure brevity in your answer.  16.84. 